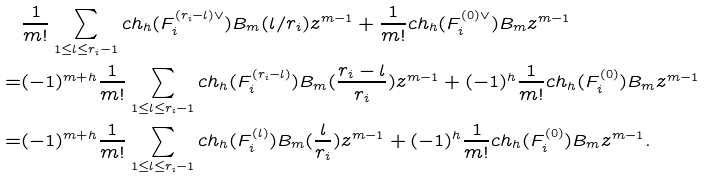Convert formula to latex. <formula><loc_0><loc_0><loc_500><loc_500>& \frac { 1 } { m ! } \sum _ { 1 \leq l \leq r _ { i } - 1 } c h _ { h } ( F _ { i } ^ { ( r _ { i } - l ) \vee } ) B _ { m } ( l / r _ { i } ) z ^ { m - 1 } + \frac { 1 } { m ! } c h _ { h } ( F _ { i } ^ { ( 0 ) \vee } ) B _ { m } z ^ { m - 1 } \\ = & ( - 1 ) ^ { m + h } \frac { 1 } { m ! } \sum _ { 1 \leq l \leq r _ { i } - 1 } c h _ { h } ( F _ { i } ^ { ( r _ { i } - l ) } ) B _ { m } ( \frac { r _ { i } - l } { r _ { i } } ) z ^ { m - 1 } + ( - 1 ) ^ { h } \frac { 1 } { m ! } c h _ { h } ( F _ { i } ^ { ( 0 ) } ) B _ { m } z ^ { m - 1 } \\ = & ( - 1 ) ^ { m + h } \frac { 1 } { m ! } \sum _ { 1 \leq l \leq r _ { i } - 1 } c h _ { h } ( F _ { i } ^ { ( l ) } ) B _ { m } ( \frac { l } { r _ { i } } ) z ^ { m - 1 } + ( - 1 ) ^ { h } \frac { 1 } { m ! } c h _ { h } ( F _ { i } ^ { ( 0 ) } ) B _ { m } z ^ { m - 1 } .</formula> 